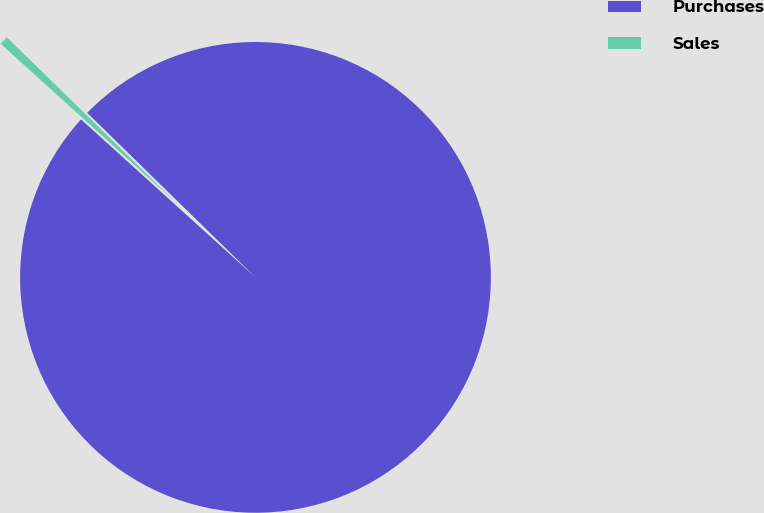<chart> <loc_0><loc_0><loc_500><loc_500><pie_chart><fcel>Purchases<fcel>Sales<nl><fcel>99.39%<fcel>0.61%<nl></chart> 